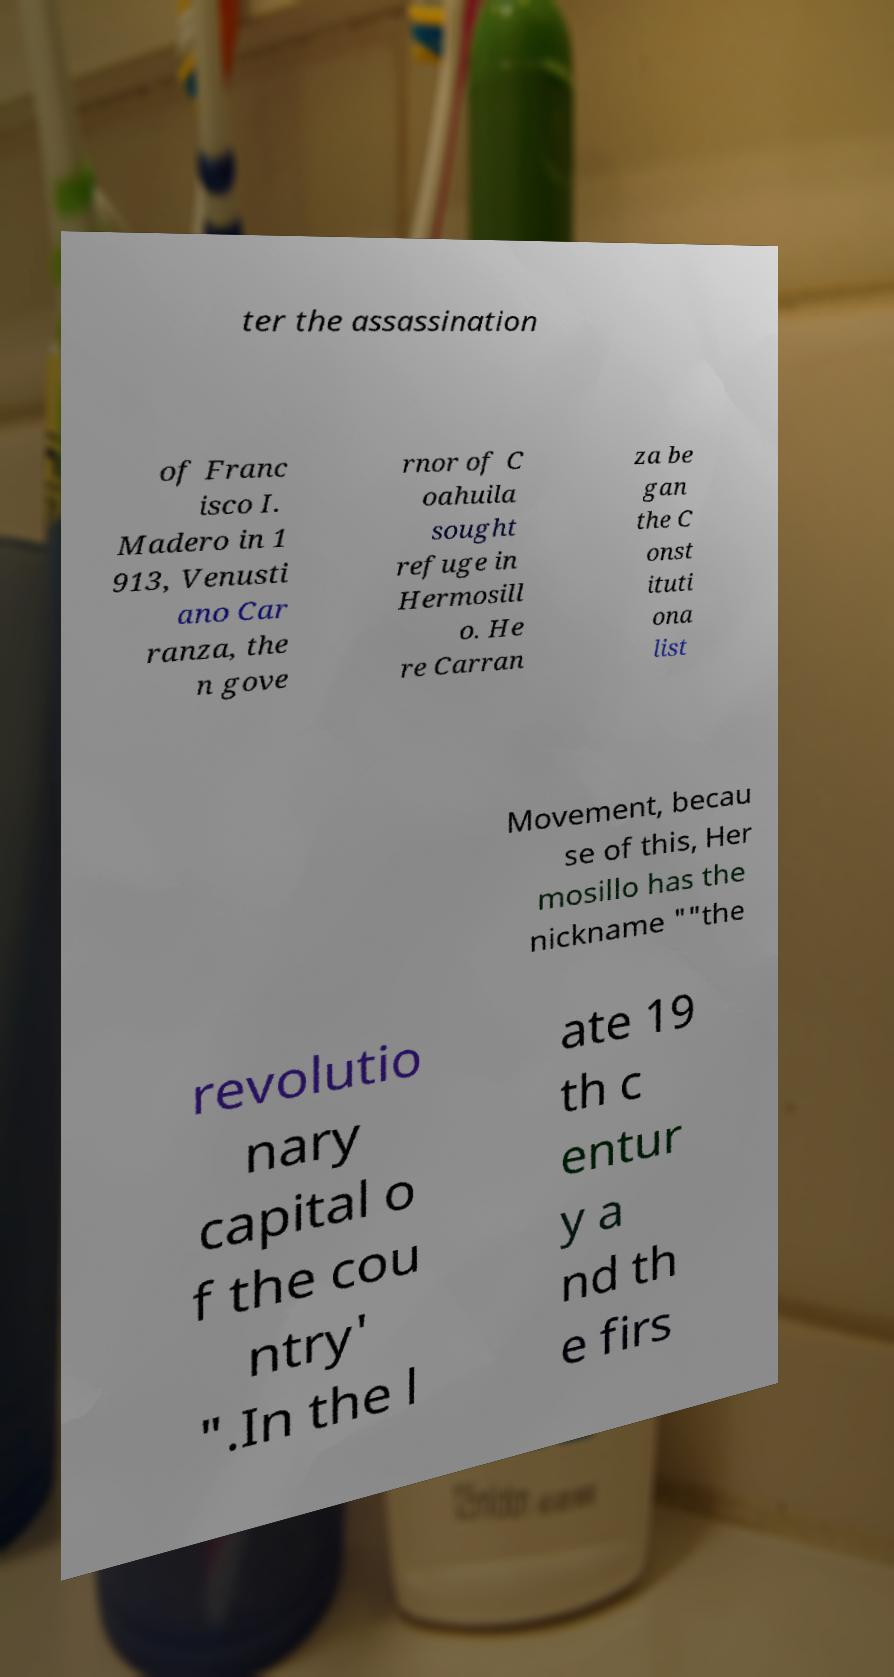For documentation purposes, I need the text within this image transcribed. Could you provide that? ter the assassination of Franc isco I. Madero in 1 913, Venusti ano Car ranza, the n gove rnor of C oahuila sought refuge in Hermosill o. He re Carran za be gan the C onst ituti ona list Movement, becau se of this, Her mosillo has the nickname ""the revolutio nary capital o f the cou ntry' ".In the l ate 19 th c entur y a nd th e firs 